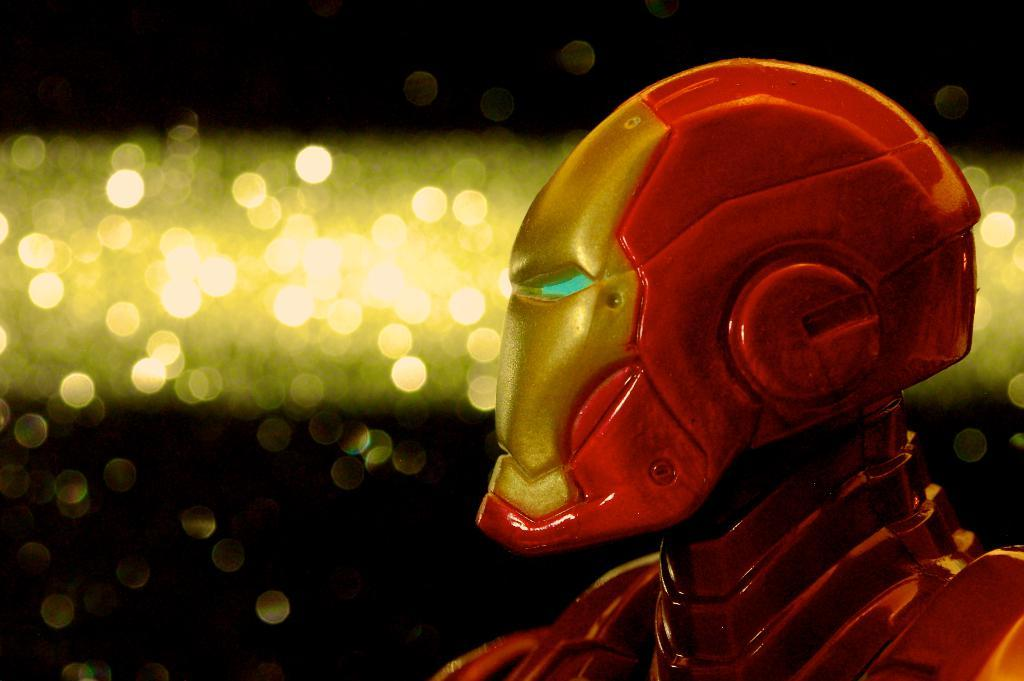What is the main subject of the image? There is a robot in the image. What else can be seen in the image besides the robot? There are lights visible in the image. How would you describe the overall appearance of the image? The background of the image is dark. Can you see a cat playing with a tin in the image? There is no cat or tin present in the image. What type of blade is being used by the robot in the image? There is no blade visible in the image, and the robot is not using any tool or object. 